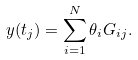<formula> <loc_0><loc_0><loc_500><loc_500>y ( t _ { j } ) = \sum _ { i = 1 } ^ { N } \theta _ { i } G _ { i j } .</formula> 